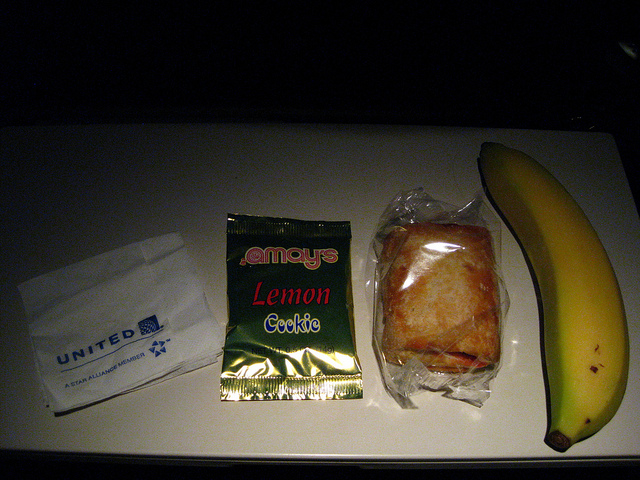<image>What message has Dave written? It is unknown what message Dave has written. It's possible that there might be no message. What message has Dave written? I don't know what message Dave has written. It seems that there is no message. 